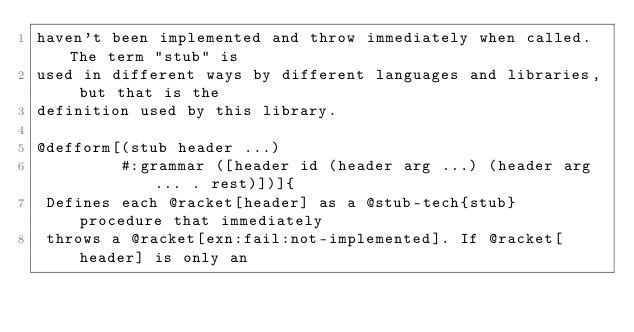<code> <loc_0><loc_0><loc_500><loc_500><_Racket_>haven't been implemented and throw immediately when called. The term "stub" is
used in different ways by different languages and libraries, but that is the
definition used by this library.

@defform[(stub header ...)
         #:grammar ([header id (header arg ...) (header arg ... . rest)])]{
 Defines each @racket[header] as a @stub-tech{stub} procedure that immediately
 throws a @racket[exn:fail:not-implemented]. If @racket[header] is only an</code> 